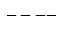Convert formula to latex. <formula><loc_0><loc_0><loc_500><loc_500>- - - -</formula> 